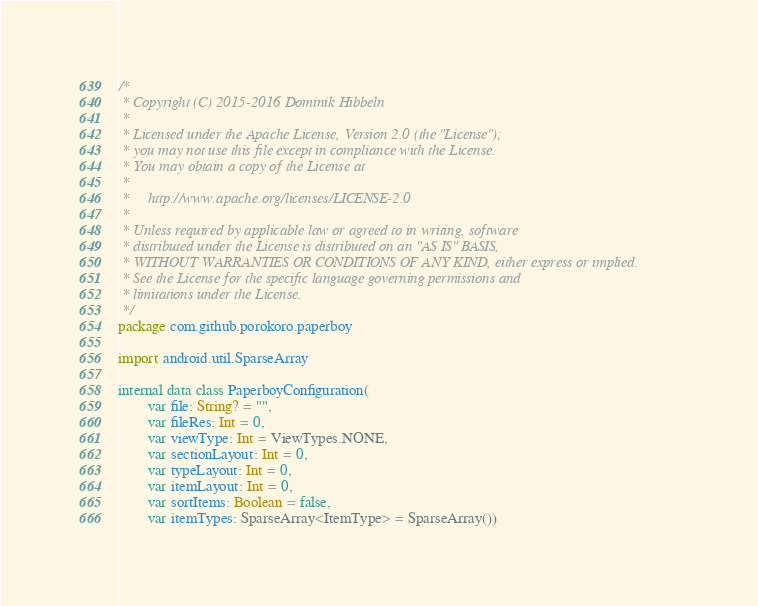Convert code to text. <code><loc_0><loc_0><loc_500><loc_500><_Kotlin_>/*
 * Copyright (C) 2015-2016 Dominik Hibbeln
 *
 * Licensed under the Apache License, Version 2.0 (the "License");
 * you may not use this file except in compliance with the License.
 * You may obtain a copy of the License at
 *
 *     http://www.apache.org/licenses/LICENSE-2.0
 *
 * Unless required by applicable law or agreed to in writing, software
 * distributed under the License is distributed on an "AS IS" BASIS,
 * WITHOUT WARRANTIES OR CONDITIONS OF ANY KIND, either express or implied.
 * See the License for the specific language governing permissions and
 * limitations under the License.
 */
package com.github.porokoro.paperboy

import android.util.SparseArray

internal data class PaperboyConfiguration(
        var file: String? = "",
        var fileRes: Int = 0,
        var viewType: Int = ViewTypes.NONE,
        var sectionLayout: Int = 0,
        var typeLayout: Int = 0,
        var itemLayout: Int = 0,
        var sortItems: Boolean = false,
        var itemTypes: SparseArray<ItemType> = SparseArray())
</code> 